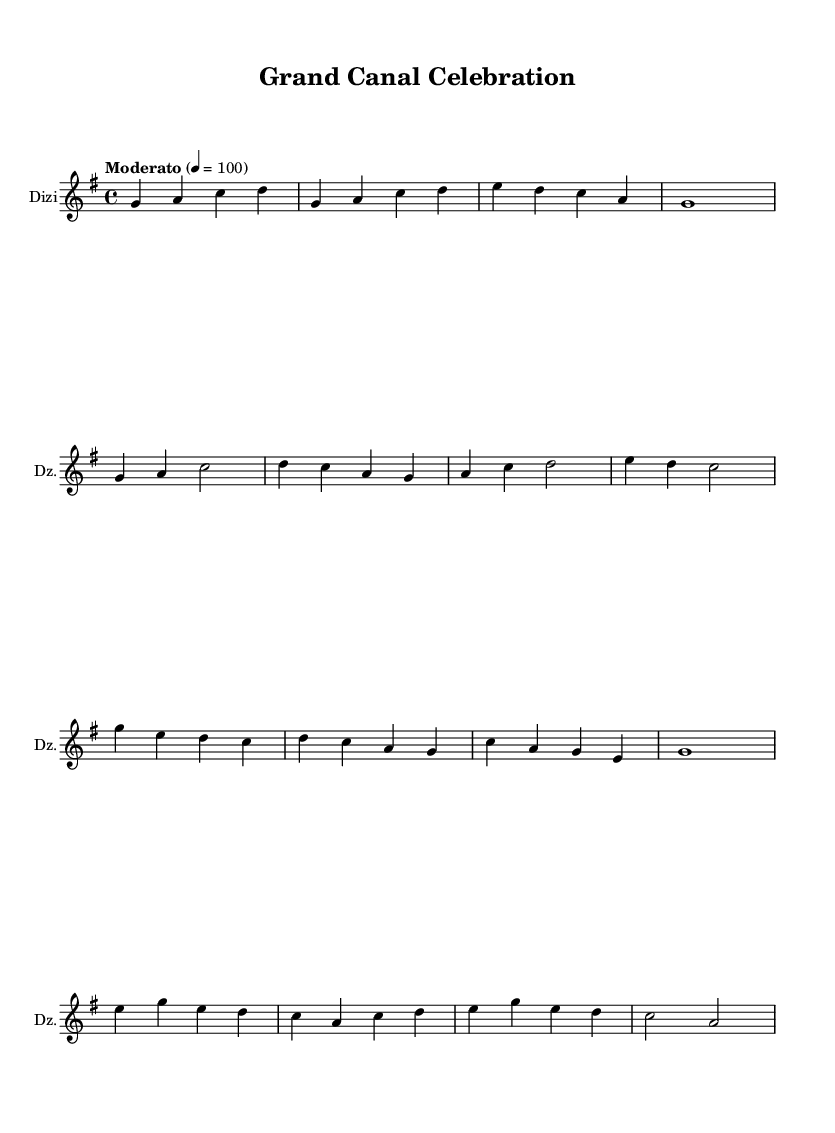What is the key signature of this music? The key signature is indicated at the beginning of the score where it shows a single sharp, which corresponds to G major.
Answer: G major What is the time signature of this music? The time signature is shown at the beginning of the score as a fraction, which is 4 over 4. This indicates that there are four beats in each measure.
Answer: 4/4 What is the tempo marking of this composition? The tempo marking is given in text, indicating the speed at which the piece should be played. It is noted as "Moderato" with a tempo of 100 beats per minute.
Answer: Moderato How many measures are in the chorus section? The chorus comprises two segments, with each segment being four measures long; thus, there are a total of eight measures in the chorus section.
Answer: 8 What instrument is primarily featured in this score? The instrument name is written at the beginning of the staff, identifying the main instrument as a Dizi, which is a traditional Chinese bamboo flute.
Answer: Dizi What are the themes expressed in the lyrics? The lyrics convey themes of history, connection, and pride related to the Grand Canal, as can be inferred from phrases like "ancient waters" and "connecting hearts."
Answer: History and connection What is the structure of the piece regarding sections? The piece has a clear structure consisting of an introduction, verse, chorus, and a bridge, indicating a traditional form that is common in folk music.
Answer: Introduction, verse, chorus, bridge 